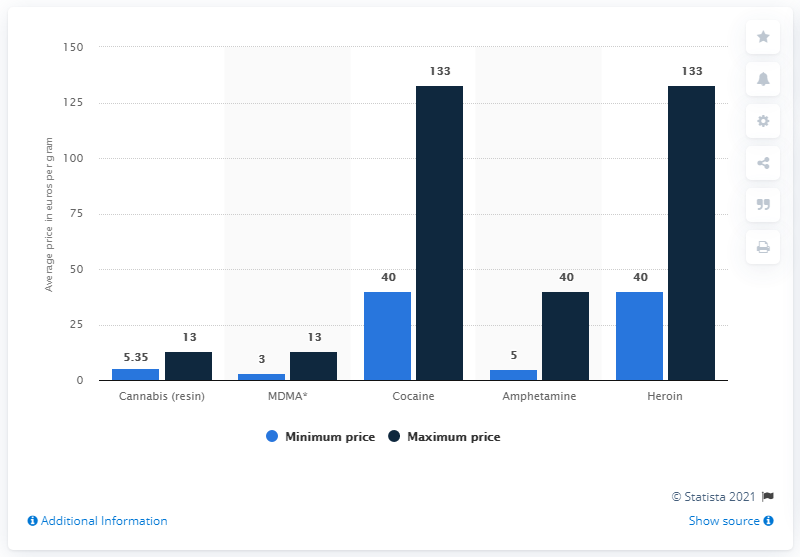Identify some key points in this picture. The value of the highest dark blue bar is 133 The lowest value in the blue bar is 3. 